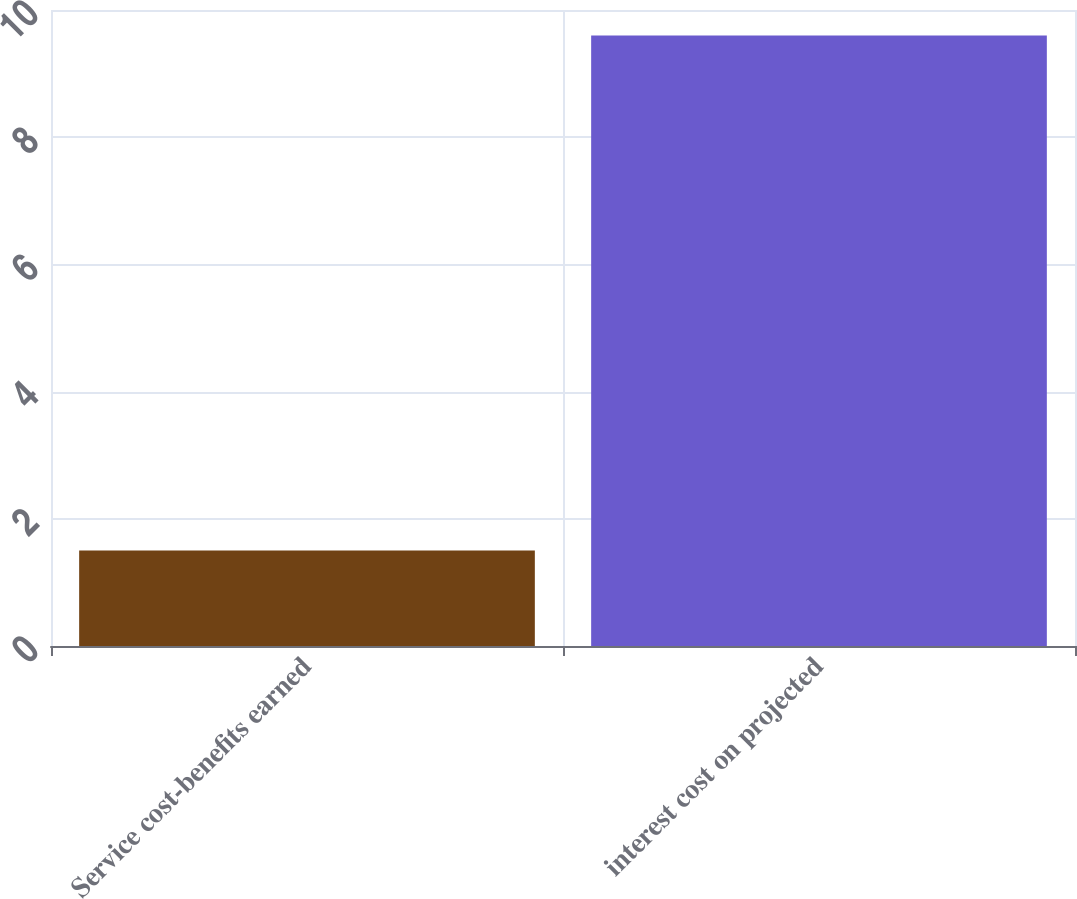<chart> <loc_0><loc_0><loc_500><loc_500><bar_chart><fcel>Service cost-benefits earned<fcel>interest cost on projected<nl><fcel>1.5<fcel>9.6<nl></chart> 